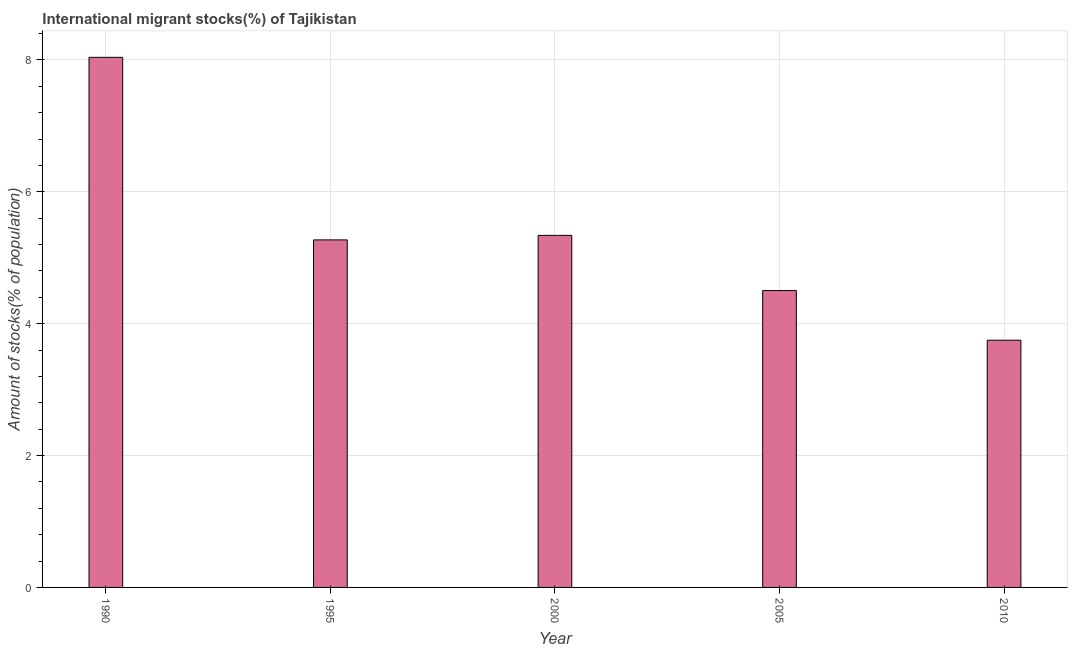Does the graph contain grids?
Give a very brief answer. Yes. What is the title of the graph?
Provide a succinct answer. International migrant stocks(%) of Tajikistan. What is the label or title of the Y-axis?
Provide a succinct answer. Amount of stocks(% of population). What is the number of international migrant stocks in 1990?
Make the answer very short. 8.04. Across all years, what is the maximum number of international migrant stocks?
Your response must be concise. 8.04. Across all years, what is the minimum number of international migrant stocks?
Provide a succinct answer. 3.75. In which year was the number of international migrant stocks maximum?
Offer a terse response. 1990. What is the sum of the number of international migrant stocks?
Offer a very short reply. 26.9. What is the difference between the number of international migrant stocks in 1995 and 2000?
Make the answer very short. -0.07. What is the average number of international migrant stocks per year?
Provide a succinct answer. 5.38. What is the median number of international migrant stocks?
Provide a succinct answer. 5.27. In how many years, is the number of international migrant stocks greater than 3.2 %?
Offer a very short reply. 5. Do a majority of the years between 1990 and 2010 (inclusive) have number of international migrant stocks greater than 5.6 %?
Provide a succinct answer. No. What is the ratio of the number of international migrant stocks in 1990 to that in 2000?
Offer a very short reply. 1.51. What is the difference between the highest and the second highest number of international migrant stocks?
Offer a terse response. 2.7. Is the sum of the number of international migrant stocks in 2000 and 2010 greater than the maximum number of international migrant stocks across all years?
Offer a terse response. Yes. What is the difference between the highest and the lowest number of international migrant stocks?
Provide a short and direct response. 4.29. How many bars are there?
Your answer should be very brief. 5. Are all the bars in the graph horizontal?
Ensure brevity in your answer.  No. How many years are there in the graph?
Give a very brief answer. 5. Are the values on the major ticks of Y-axis written in scientific E-notation?
Keep it short and to the point. No. What is the Amount of stocks(% of population) in 1990?
Provide a succinct answer. 8.04. What is the Amount of stocks(% of population) of 1995?
Give a very brief answer. 5.27. What is the Amount of stocks(% of population) of 2000?
Give a very brief answer. 5.34. What is the Amount of stocks(% of population) in 2005?
Offer a terse response. 4.5. What is the Amount of stocks(% of population) of 2010?
Give a very brief answer. 3.75. What is the difference between the Amount of stocks(% of population) in 1990 and 1995?
Offer a terse response. 2.77. What is the difference between the Amount of stocks(% of population) in 1990 and 2000?
Provide a succinct answer. 2.7. What is the difference between the Amount of stocks(% of population) in 1990 and 2005?
Your response must be concise. 3.54. What is the difference between the Amount of stocks(% of population) in 1990 and 2010?
Offer a terse response. 4.29. What is the difference between the Amount of stocks(% of population) in 1995 and 2000?
Offer a terse response. -0.07. What is the difference between the Amount of stocks(% of population) in 1995 and 2005?
Your response must be concise. 0.77. What is the difference between the Amount of stocks(% of population) in 1995 and 2010?
Offer a terse response. 1.52. What is the difference between the Amount of stocks(% of population) in 2000 and 2005?
Offer a very short reply. 0.84. What is the difference between the Amount of stocks(% of population) in 2000 and 2010?
Offer a terse response. 1.59. What is the difference between the Amount of stocks(% of population) in 2005 and 2010?
Provide a short and direct response. 0.75. What is the ratio of the Amount of stocks(% of population) in 1990 to that in 1995?
Provide a short and direct response. 1.52. What is the ratio of the Amount of stocks(% of population) in 1990 to that in 2000?
Keep it short and to the point. 1.51. What is the ratio of the Amount of stocks(% of population) in 1990 to that in 2005?
Keep it short and to the point. 1.79. What is the ratio of the Amount of stocks(% of population) in 1990 to that in 2010?
Make the answer very short. 2.14. What is the ratio of the Amount of stocks(% of population) in 1995 to that in 2005?
Provide a succinct answer. 1.17. What is the ratio of the Amount of stocks(% of population) in 1995 to that in 2010?
Offer a very short reply. 1.41. What is the ratio of the Amount of stocks(% of population) in 2000 to that in 2005?
Your answer should be very brief. 1.19. What is the ratio of the Amount of stocks(% of population) in 2000 to that in 2010?
Your answer should be very brief. 1.42. What is the ratio of the Amount of stocks(% of population) in 2005 to that in 2010?
Your response must be concise. 1.2. 